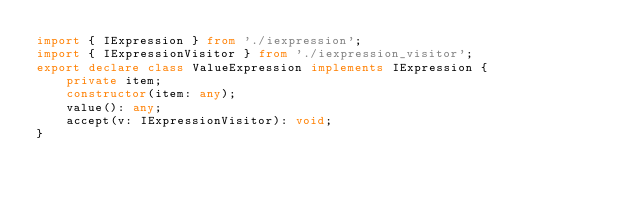<code> <loc_0><loc_0><loc_500><loc_500><_TypeScript_>import { IExpression } from './iexpression';
import { IExpressionVisitor } from './iexpression_visitor';
export declare class ValueExpression implements IExpression {
    private item;
    constructor(item: any);
    value(): any;
    accept(v: IExpressionVisitor): void;
}
</code> 